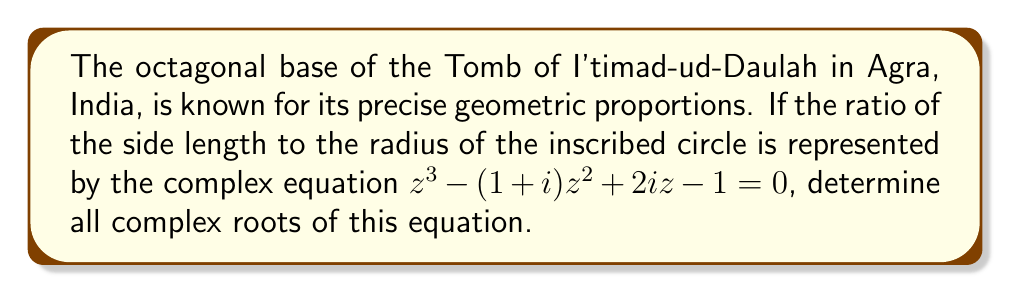What is the answer to this math problem? To solve this cubic equation, we'll use the following steps:

1) First, let's apply the rational root theorem to find if there are any real roots. The possible rational roots are $\pm 1, \pm i$.

2) By substitution, we find that $z = 1$ is a root of the equation:
   $1^3 - (1+i)1^2 + 2i(1) - 1 = 1 - (1+i) + 2i - 1 = -i + 2i = i = 0$

3) Now that we have one root, we can factor out $(z-1)$ from the original equation:

   $z^3 - (1+i)z^2 + 2iz - 1 = (z-1)(z^2 - iz + 1)$

4) We're left with a quadratic equation to solve: $z^2 - iz + 1 = 0$

5) We can solve this using the quadratic formula: $z = \frac{-b \pm \sqrt{b^2-4ac}}{2a}$

   Here, $a=1$, $b=-i$, and $c=1$

6) Substituting into the quadratic formula:

   $z = \frac{i \pm \sqrt{(-i)^2-4(1)(1)}}{2(1)} = \frac{i \pm \sqrt{-1-4}}{2} = \frac{i \pm \sqrt{-5}}{2}$

7) Simplify $\sqrt{-5}$:
   $\sqrt{-5} = i\sqrt{5}$

8) Therefore, the other two roots are:

   $z = \frac{i \pm i\sqrt{5}}{2} = \frac{i(1 \pm \sqrt{5})}{2}$
Answer: The complex roots of the equation are:
$z_1 = 1$
$z_2 = \frac{i(1 + \sqrt{5})}{2}$
$z_3 = \frac{i(1 - \sqrt{5})}{2}$ 